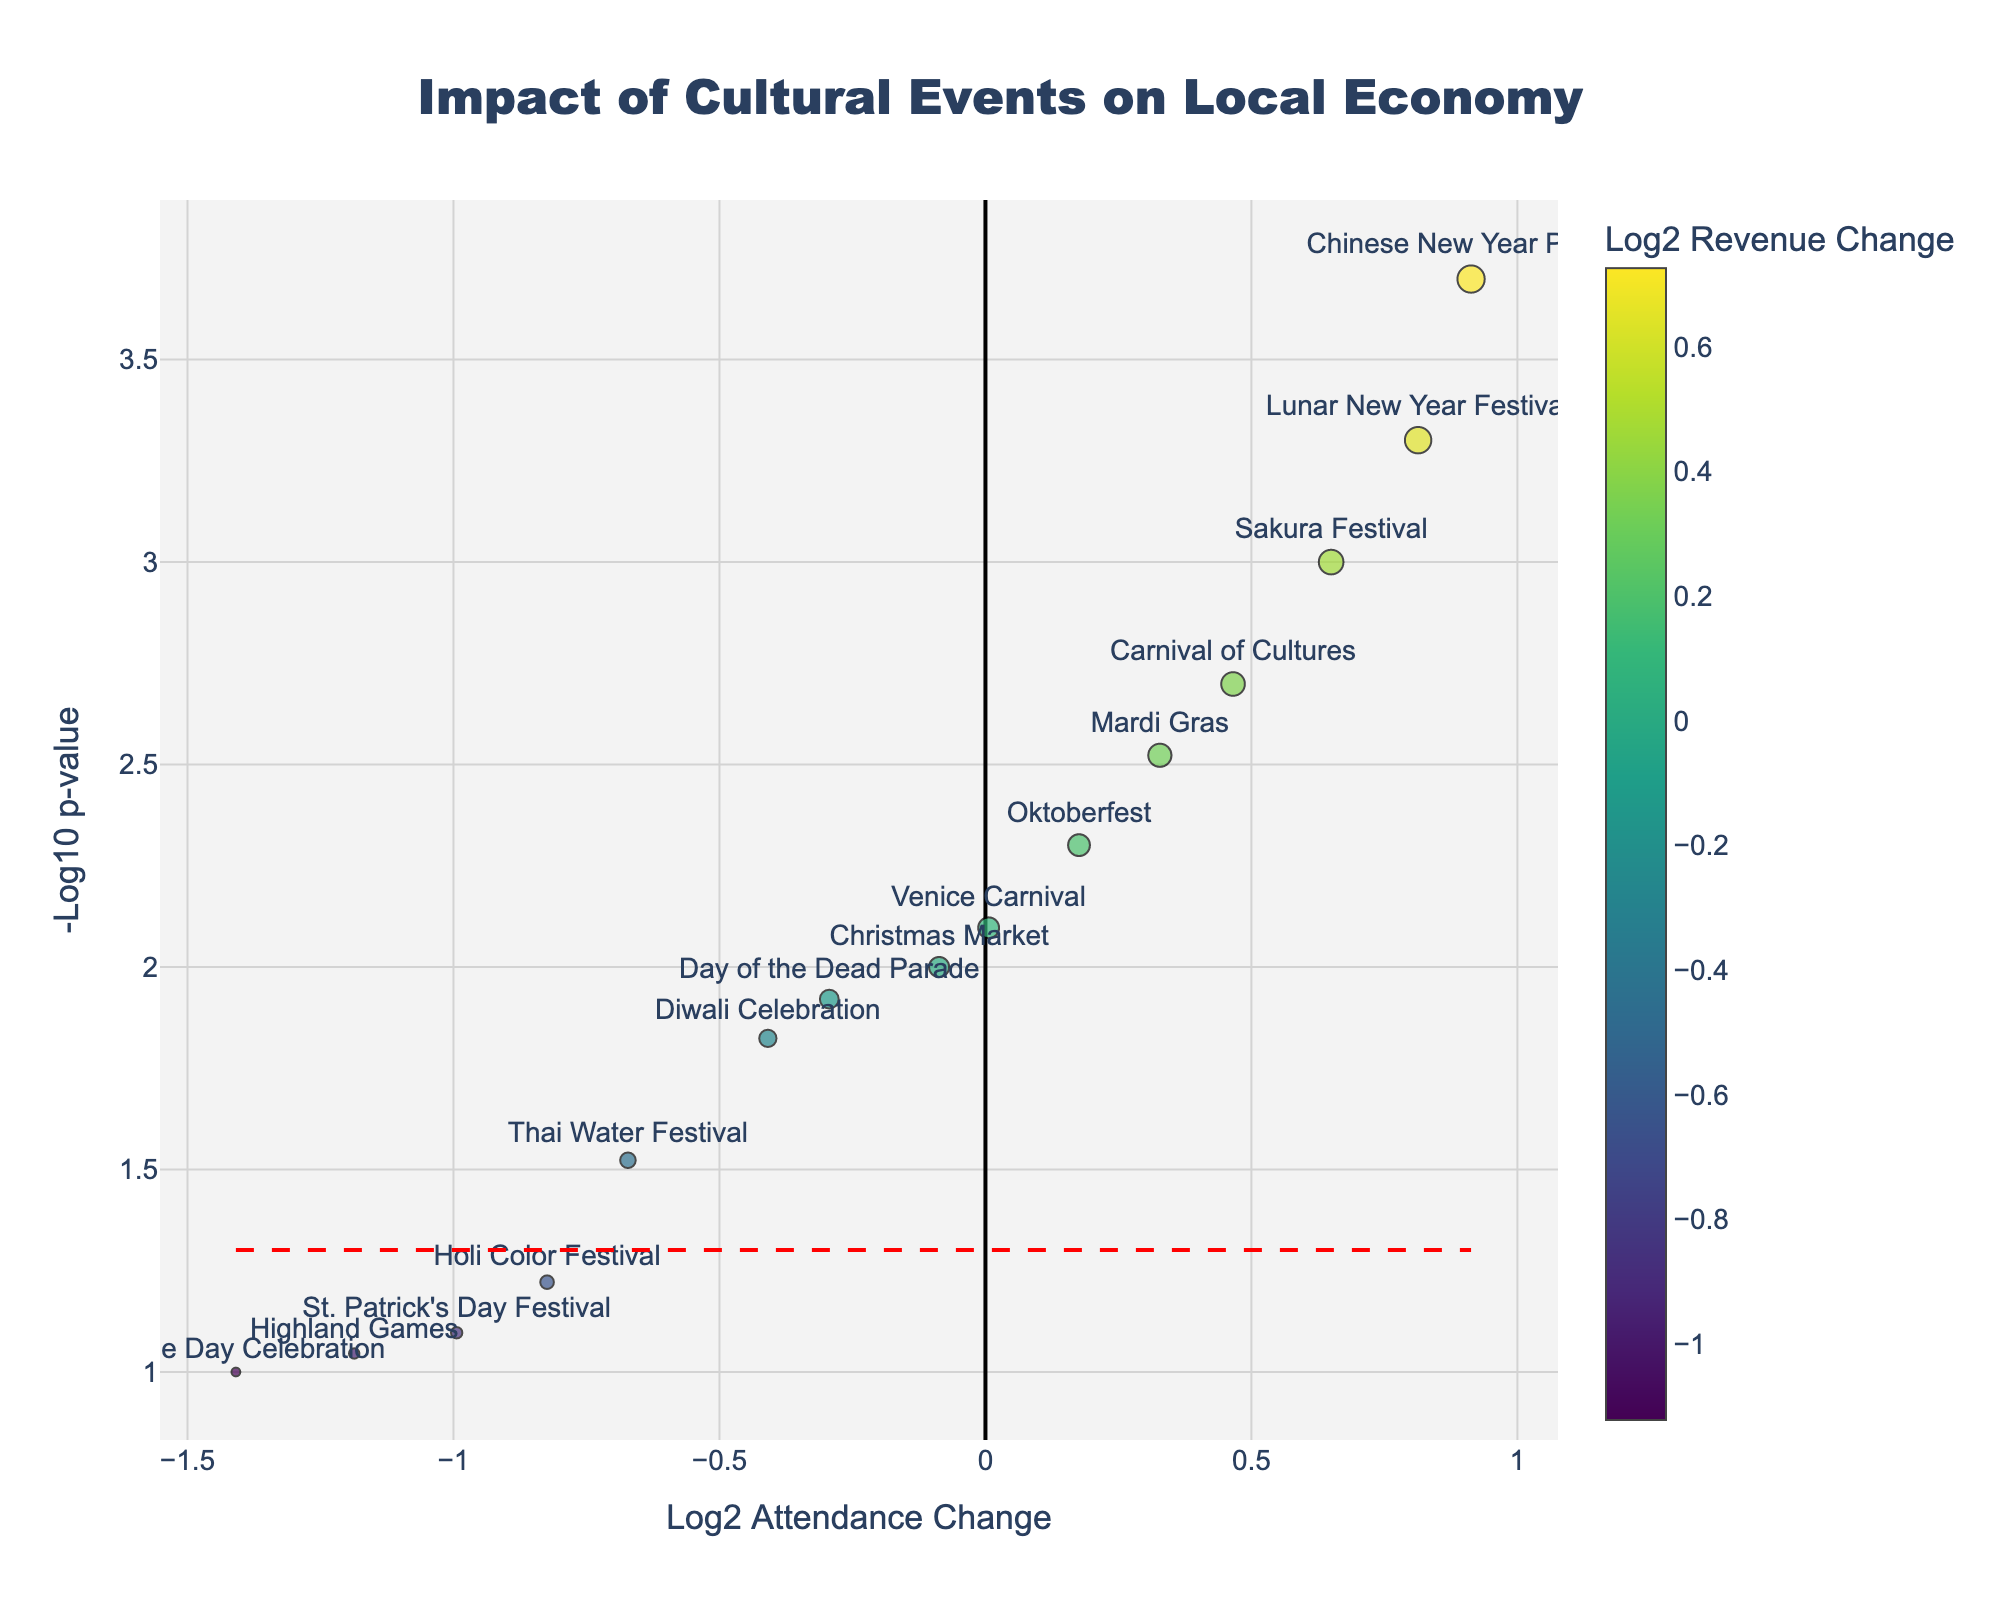What is the title of the figure? The title of the figure can be found at the top of the plot. In this case, it is centered and states "Impact of Cultural Events on Local Economy".
Answer: Impact of Cultural Events on Local Economy How many events are shown in the figure? Each data point represents an event, and we can count them. By analyzing the plot, we see there are 15 events labeled.
Answer: 15 Which event has the highest -log10 p-value? The -log10 p-value is represented by the y-axis. The event with the highest value will be at the topmost position on the plot. In this case, the Chinese New Year Parade is the topmost event.
Answer: Chinese New Year Parade Which event has the lowest log2 attendance change and what is its value? The log2 attendance change is represented by the x-axis. The event with the lowest log2 attendance change will be the leftmost point. St. Patrick's Day Festival is the leftmost point, indicating the lowest value. Its exact log2 value can be found from the hover data or axis ticks.
Answer: St. Patrick's Day Festival; approximately -0.9 How does the log2 revenue change for Carnival of Cultures compare to Lunar New Year Festival? Compare the marker color (representing log2 revenue change) for the Carnival of Cultures and Lunar New Year Festival. The color scale indicates that the log2 revenue change for Lunar New Year Festival (darker color) is greater than Carnival of Cultures.
Answer: Lunar New Year Festival has a higher log2 revenue change than Carnival of Cultures What does the red dashed horizontal line represent? The red dashed horizontal line is drawn at a specific y-axis value, corresponding to -log10(p-value) = 1.3 (based on the hover info or axis ticks). This represents the p-value threshold of 0.05, so events above this line have a p-value less than 0.05.
Answer: P-value threshold of 0.05 Which event has the highest log2 revenue change, and what is its approximate value? The log2 revenue change is shown by the color intensity of the markers. The Chinese New Year Parade has the most intense color, indicating the highest revenue change with a log2 value visible through hover data.
Answer: Chinese New Year Parade; approximately 1.2 What is the log2 attendance change range in the plot? The range is defined by the minimum and maximum log2 attendance changes observed along the x-axis. By looking at the leftmost and rightmost points on the plot, we can estimate the range. It spans from around -0.9 (St. Patrick's Day Festival) to around 1.4 (Chinese New Year Parade).
Answer: From approximately -0.9 to 1.4 Which events have a p-value greater than 0.05? According to the plot, events below the red dashed horizontal line (which represents p-value 0.05) have a p-value greater than 0.05. These events are St. Patrick's Day Festival, Bastille Day Celebration, Holi Color Festival, and Highland Games.
Answer: St. Patrick's Day Festival, Bastille Day Celebration, Holi Color Festival, Highland Games 